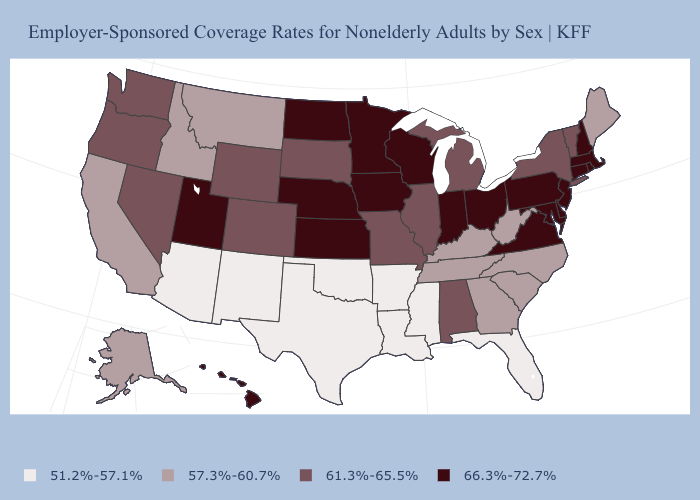Name the states that have a value in the range 51.2%-57.1%?
Give a very brief answer. Arizona, Arkansas, Florida, Louisiana, Mississippi, New Mexico, Oklahoma, Texas. Among the states that border Nevada , which have the lowest value?
Be succinct. Arizona. Which states have the lowest value in the Northeast?
Give a very brief answer. Maine. What is the value of Pennsylvania?
Quick response, please. 66.3%-72.7%. Is the legend a continuous bar?
Quick response, please. No. Name the states that have a value in the range 66.3%-72.7%?
Write a very short answer. Connecticut, Delaware, Hawaii, Indiana, Iowa, Kansas, Maryland, Massachusetts, Minnesota, Nebraska, New Hampshire, New Jersey, North Dakota, Ohio, Pennsylvania, Rhode Island, Utah, Virginia, Wisconsin. Does California have a higher value than Arkansas?
Quick response, please. Yes. Does Georgia have the highest value in the South?
Short answer required. No. Does Minnesota have the highest value in the MidWest?
Keep it brief. Yes. What is the value of Louisiana?
Give a very brief answer. 51.2%-57.1%. Which states have the lowest value in the Northeast?
Keep it brief. Maine. Which states have the highest value in the USA?
Write a very short answer. Connecticut, Delaware, Hawaii, Indiana, Iowa, Kansas, Maryland, Massachusetts, Minnesota, Nebraska, New Hampshire, New Jersey, North Dakota, Ohio, Pennsylvania, Rhode Island, Utah, Virginia, Wisconsin. Does Colorado have a lower value than Vermont?
Give a very brief answer. No. Which states have the lowest value in the USA?
Answer briefly. Arizona, Arkansas, Florida, Louisiana, Mississippi, New Mexico, Oklahoma, Texas. What is the value of Virginia?
Keep it brief. 66.3%-72.7%. 